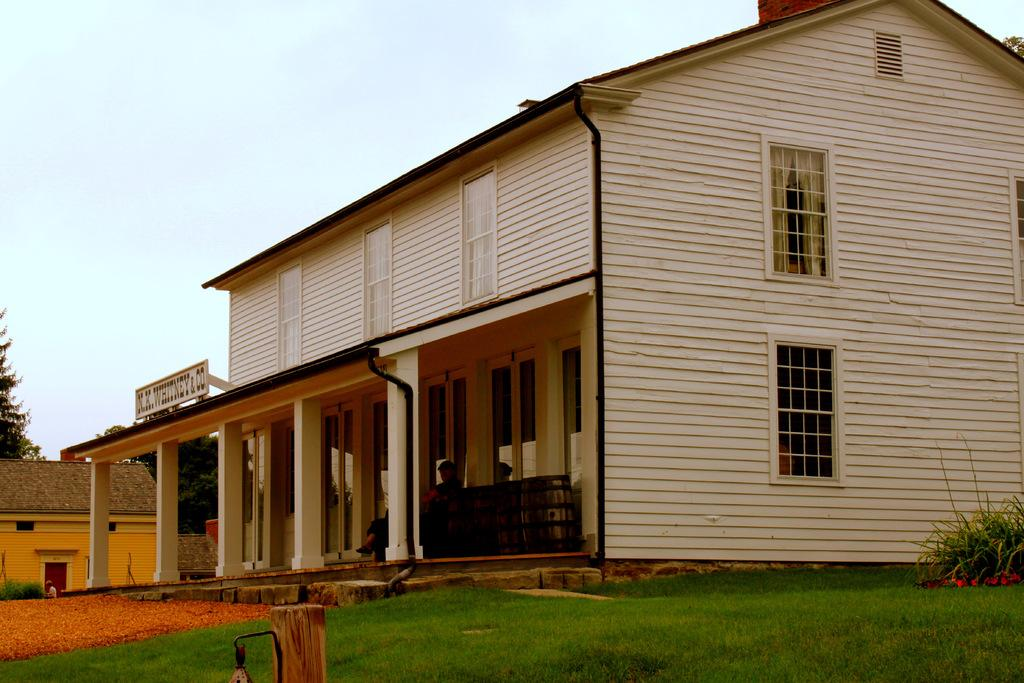What type of landscape is depicted in the image? There is a grassland in the image. What structures can be seen in the background of the image? There are houses and trees in the background of the image. What else is visible in the background of the image? The sky is visible in the background of the image. Where is the cemetery located in the image? There is no cemetery present in the image. What key is used to unlock the door of the house in the image? There is no mention of a key or a locked door in the image. 